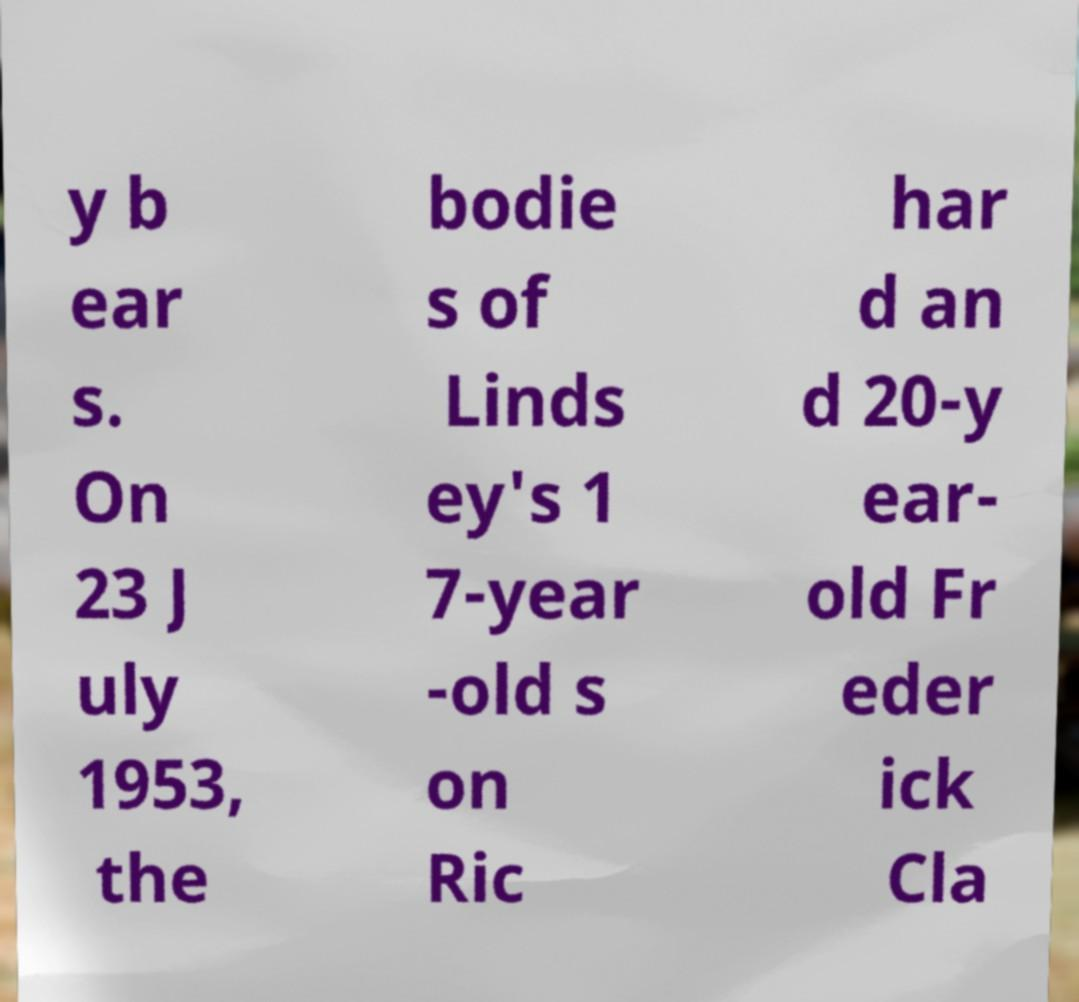For documentation purposes, I need the text within this image transcribed. Could you provide that? y b ear s. On 23 J uly 1953, the bodie s of Linds ey's 1 7-year -old s on Ric har d an d 20-y ear- old Fr eder ick Cla 